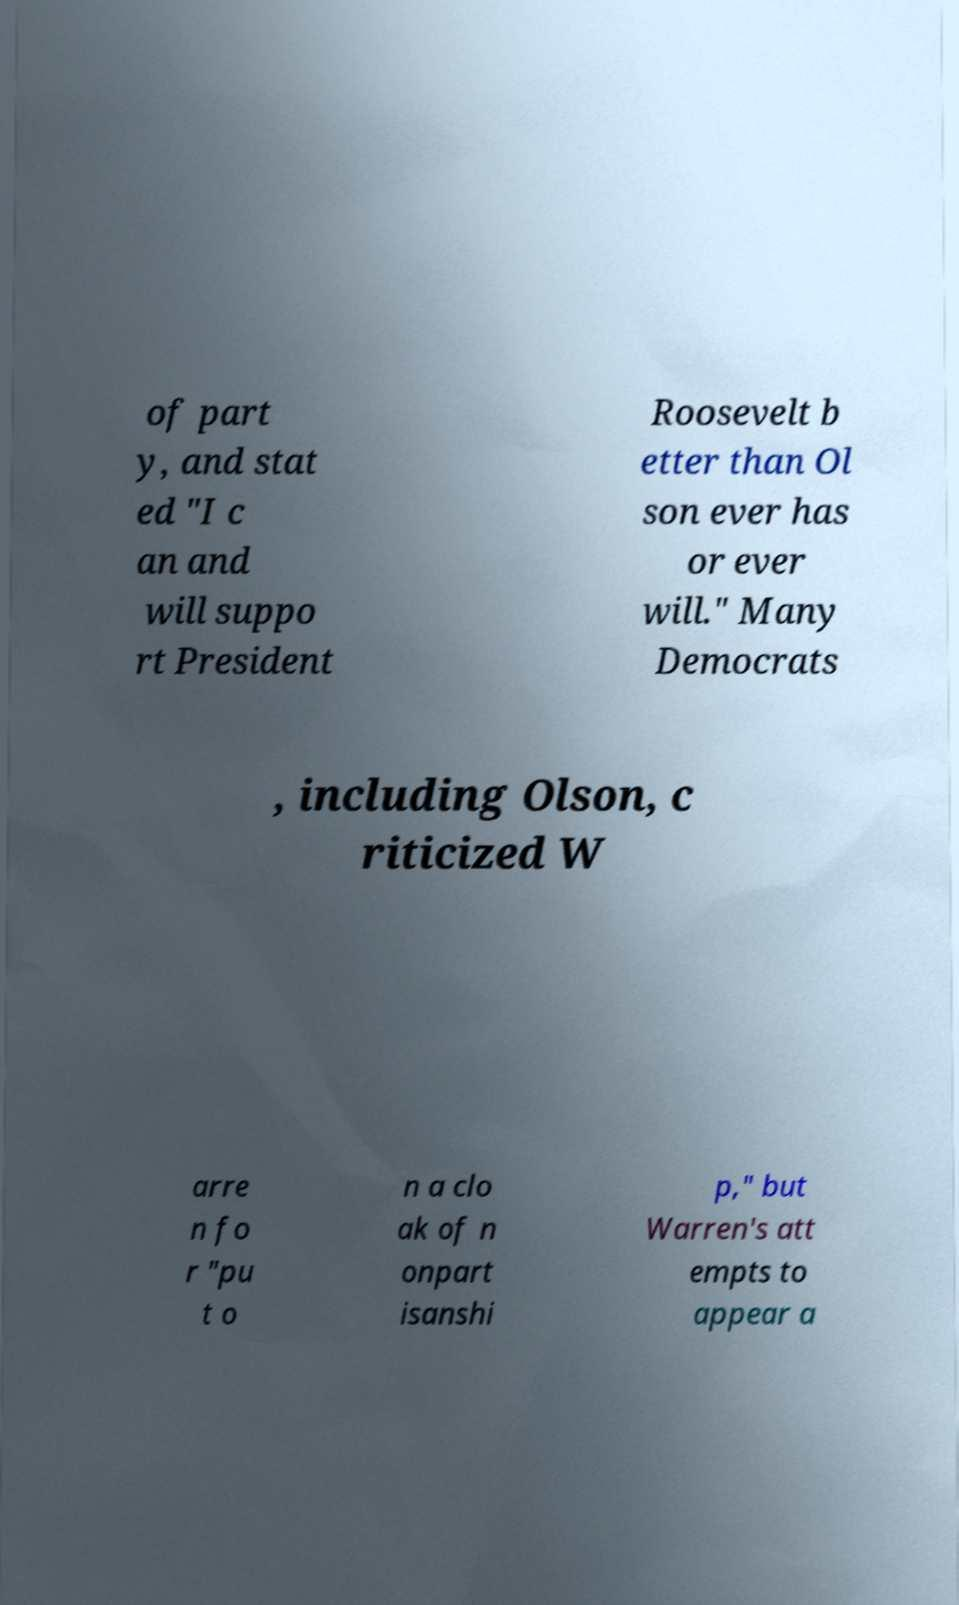There's text embedded in this image that I need extracted. Can you transcribe it verbatim? of part y, and stat ed "I c an and will suppo rt President Roosevelt b etter than Ol son ever has or ever will." Many Democrats , including Olson, c riticized W arre n fo r "pu t o n a clo ak of n onpart isanshi p," but Warren's att empts to appear a 